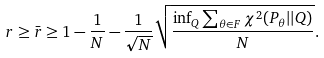<formula> <loc_0><loc_0><loc_500><loc_500>r \geq \bar { r } \geq 1 - \frac { 1 } { N } - \frac { 1 } { \sqrt { N } } \sqrt { \frac { \inf _ { Q } \sum _ { \theta \in F } \chi ^ { 2 } ( P _ { \theta } | | Q ) } { N } } .</formula> 